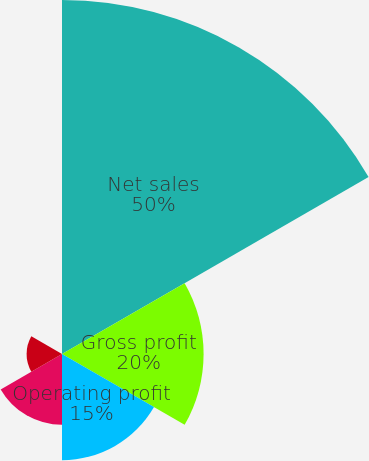Convert chart. <chart><loc_0><loc_0><loc_500><loc_500><pie_chart><fcel>Net sales<fcel>Gross profit<fcel>Operating profit<fcel>Net income<fcel>Basic earnings per share<fcel>Diluted earnings per share<nl><fcel>50.0%<fcel>20.0%<fcel>15.0%<fcel>10.0%<fcel>5.0%<fcel>0.0%<nl></chart> 